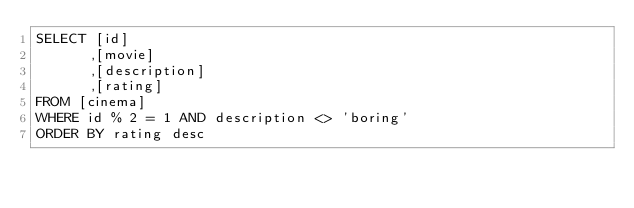<code> <loc_0><loc_0><loc_500><loc_500><_SQL_>SELECT [id]
      ,[movie]
      ,[description]
      ,[rating]
FROM [cinema]
WHERE id % 2 = 1 AND description <> 'boring'
ORDER BY rating desc</code> 